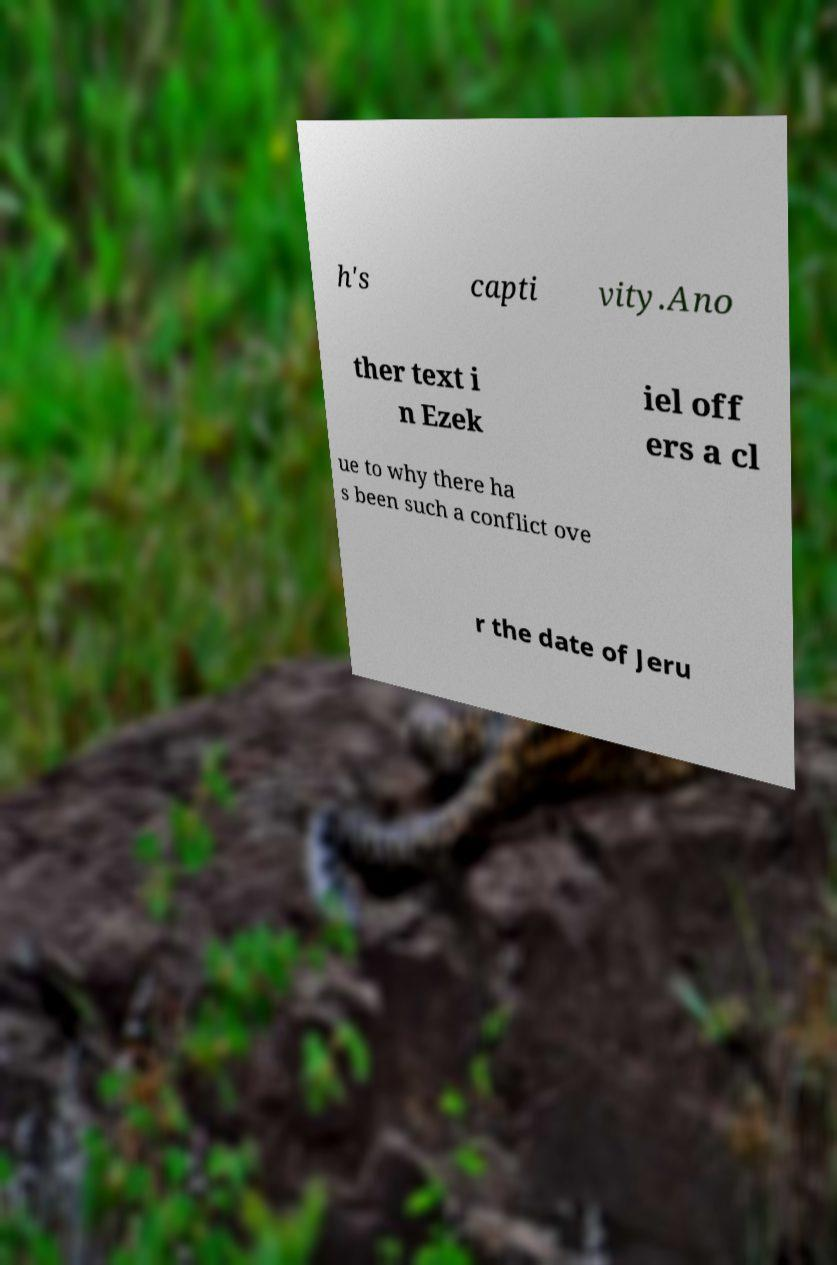What messages or text are displayed in this image? I need them in a readable, typed format. h's capti vity.Ano ther text i n Ezek iel off ers a cl ue to why there ha s been such a conflict ove r the date of Jeru 